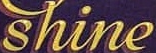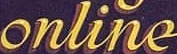Read the text content from these images in order, separated by a semicolon. shine; online 